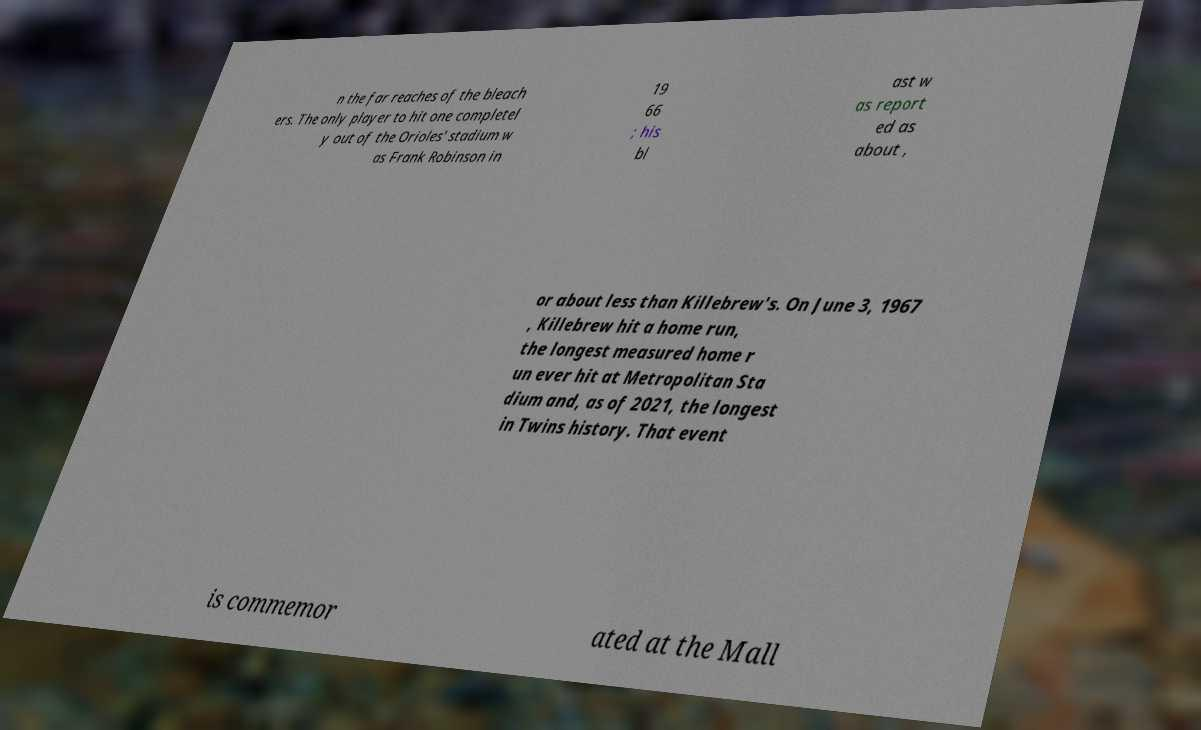I need the written content from this picture converted into text. Can you do that? n the far reaches of the bleach ers. The only player to hit one completel y out of the Orioles' stadium w as Frank Robinson in 19 66 ; his bl ast w as report ed as about , or about less than Killebrew's. On June 3, 1967 , Killebrew hit a home run, the longest measured home r un ever hit at Metropolitan Sta dium and, as of 2021, the longest in Twins history. That event is commemor ated at the Mall 